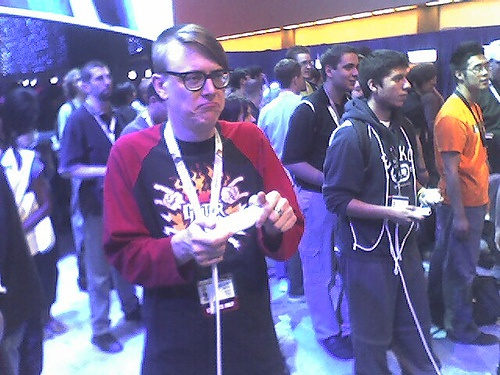Describe the objects in this image and their specific colors. I can see people in violet, navy, lavender, and purple tones, people in violet, purple, navy, blue, and lavender tones, people in violet, purple, navy, and brown tones, people in violet, blue, navy, and purple tones, and people in violet, blue, and navy tones in this image. 